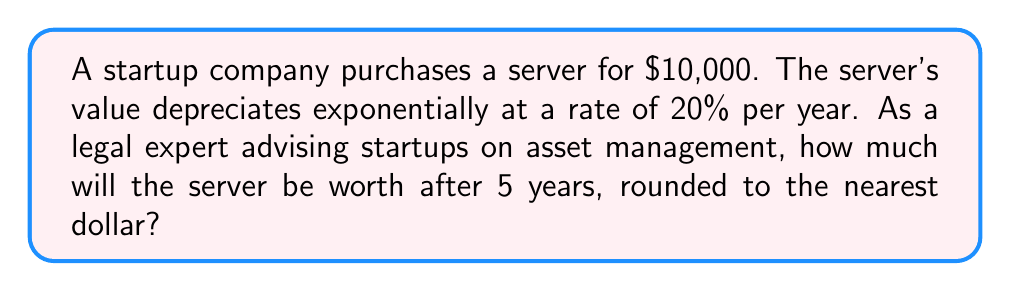Give your solution to this math problem. To solve this problem, we'll use the exponential decay formula:

$$A = P(1-r)^t$$

Where:
$A$ = Final amount
$P$ = Initial principal balance
$r$ = Depreciation rate (as a decimal)
$t$ = Time in years

Given:
$P = $10,000
$r = 0.20$ (20% expressed as a decimal)
$t = 5$ years

Let's substitute these values into the formula:

$$A = 10,000(1-0.20)^5$$

Simplify:
$$A = 10,000(0.80)^5$$

Calculate the power:
$$A = 10,000 * 0.32768$$

Multiply:
$$A = 3,276.80$$

Rounding to the nearest dollar:
$$A ≈ $3,277$$
Answer: $3,277 